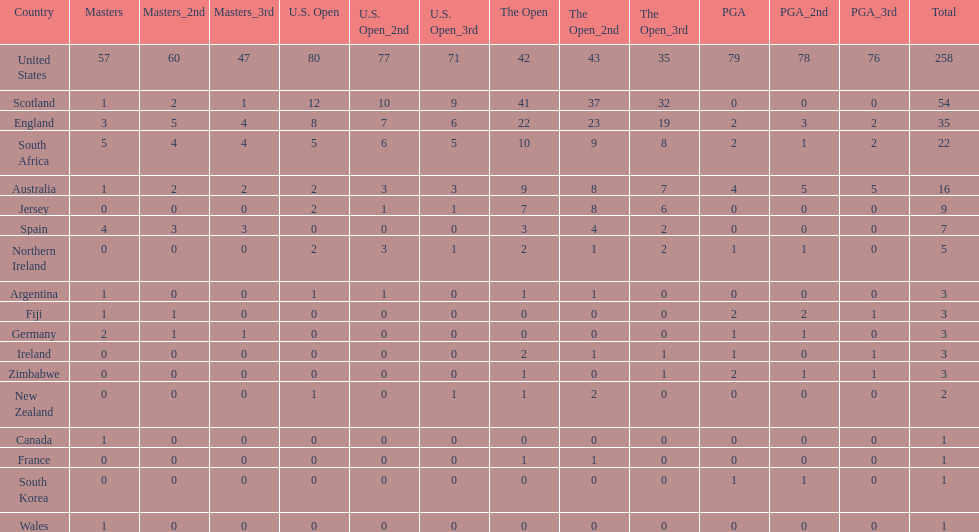What are the number of pga winning golfers that zimbabwe has? 2. 